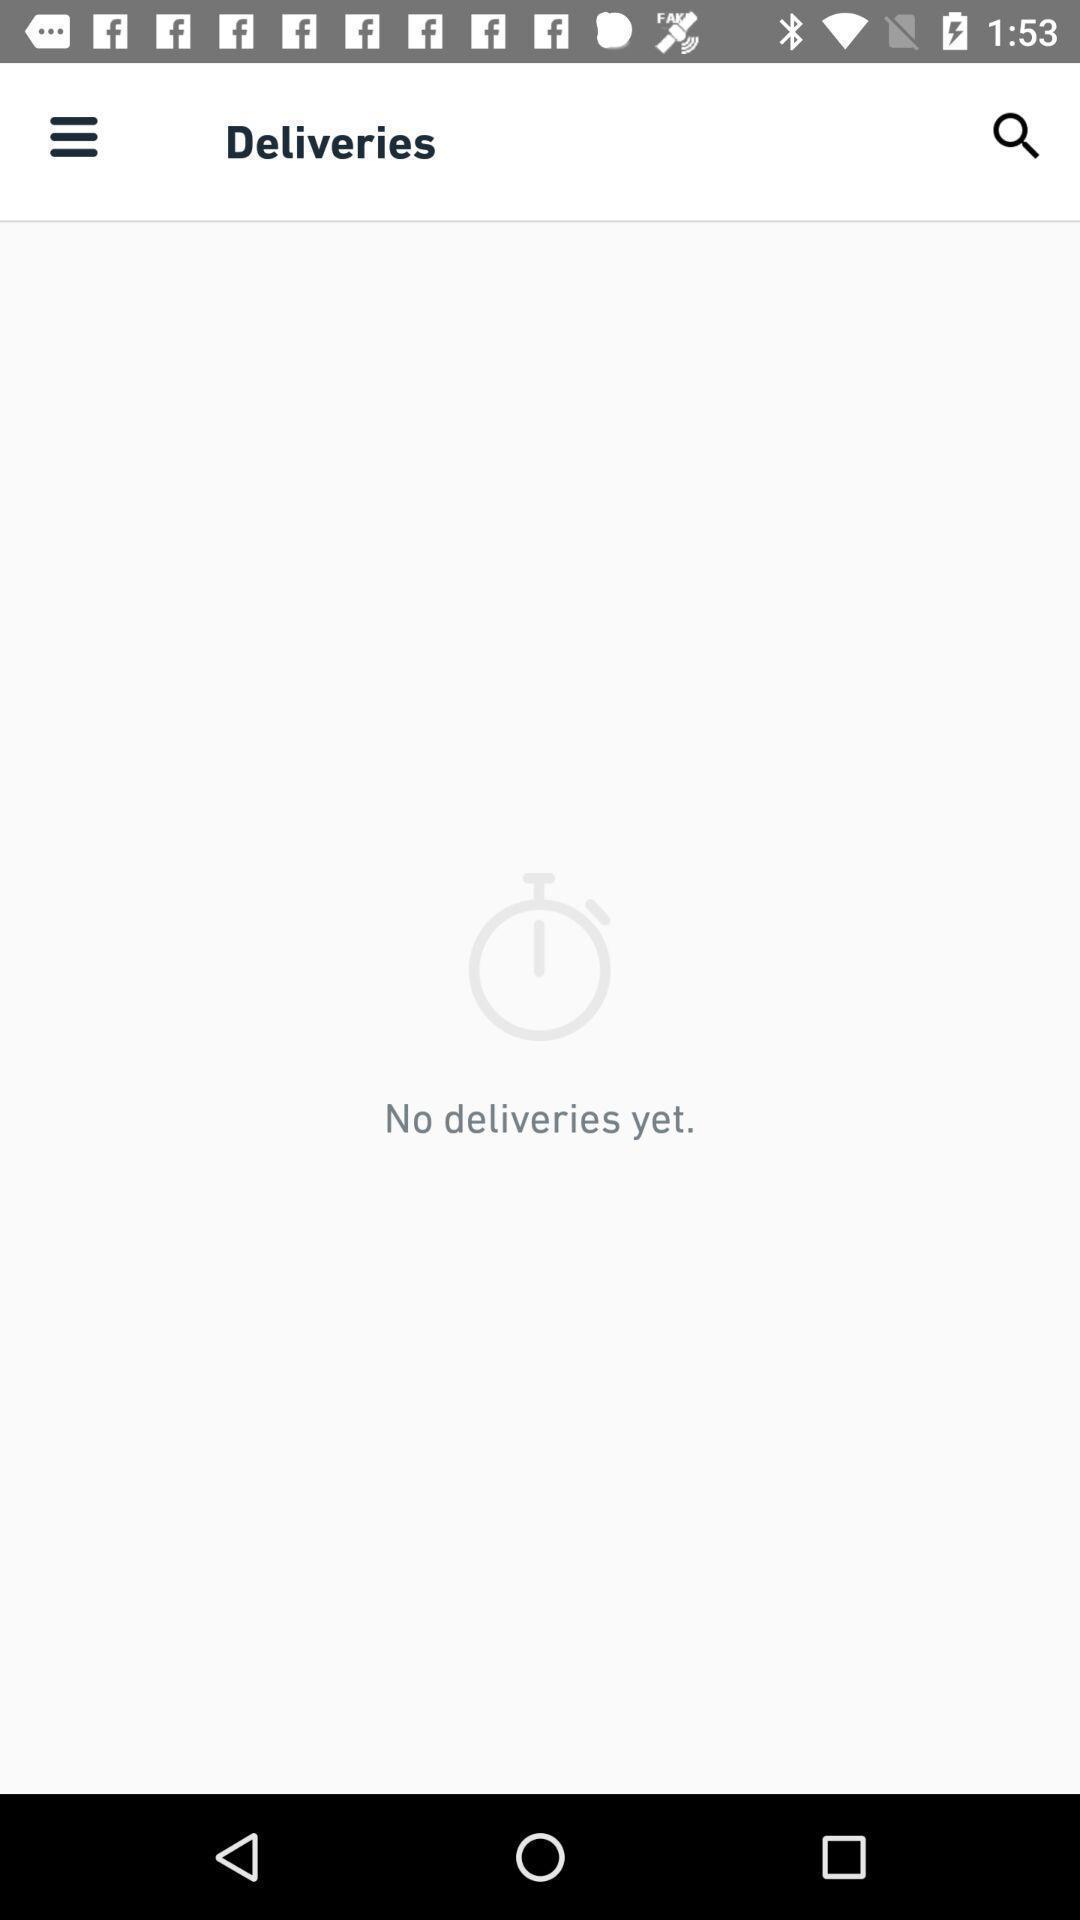Please provide a description for this image. Screen shows deliveries page in the food application. 